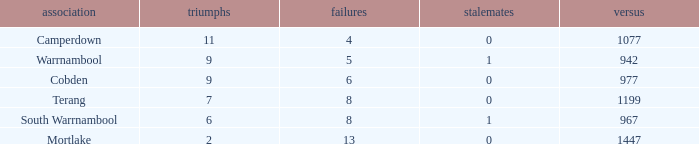What was the total number of losses with 11 or more wins and no tied games? 0.0. 